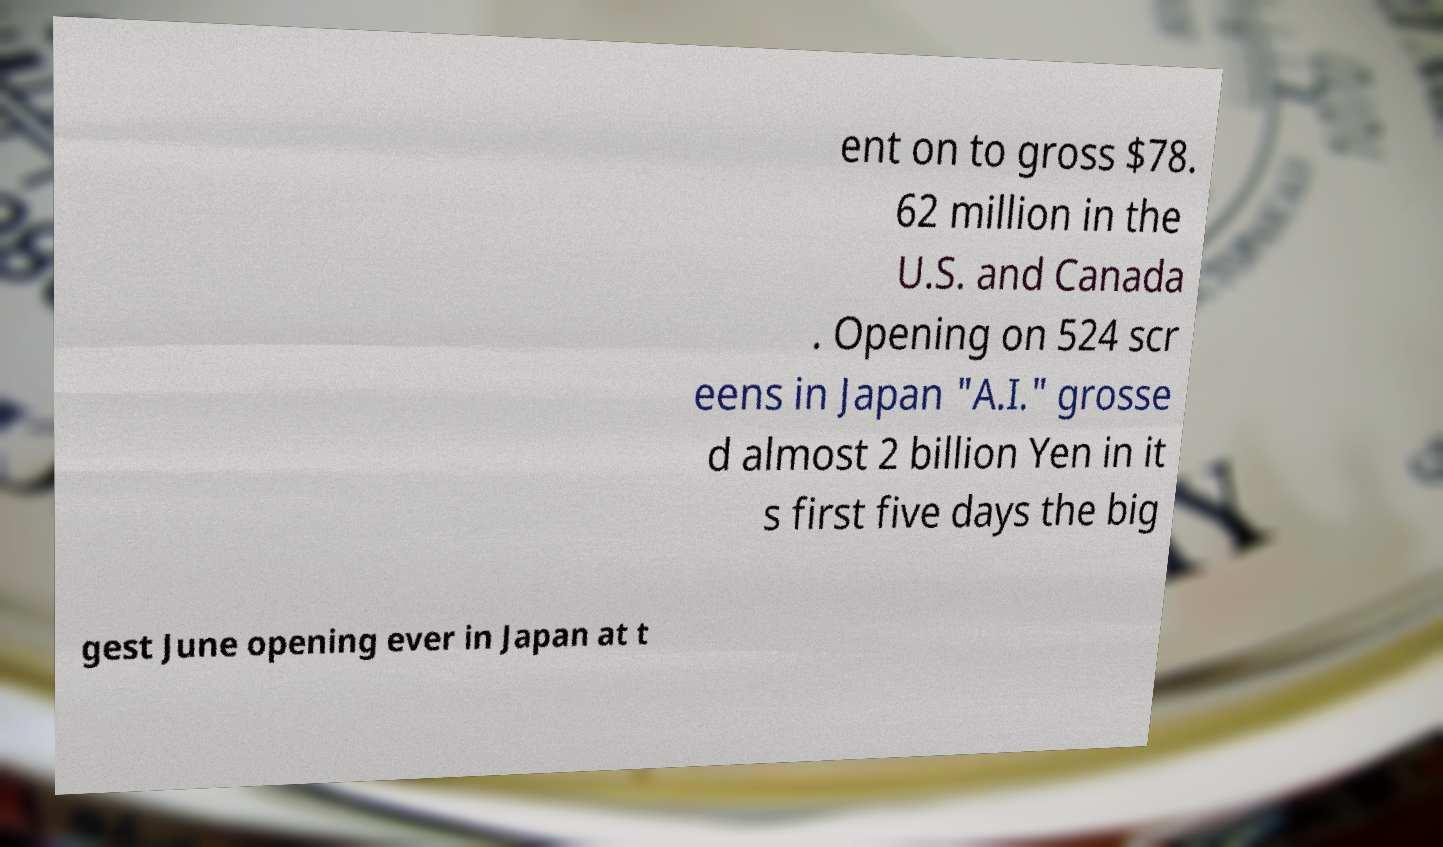For documentation purposes, I need the text within this image transcribed. Could you provide that? ent on to gross $78. 62 million in the U.S. and Canada . Opening on 524 scr eens in Japan "A.I." grosse d almost 2 billion Yen in it s first five days the big gest June opening ever in Japan at t 